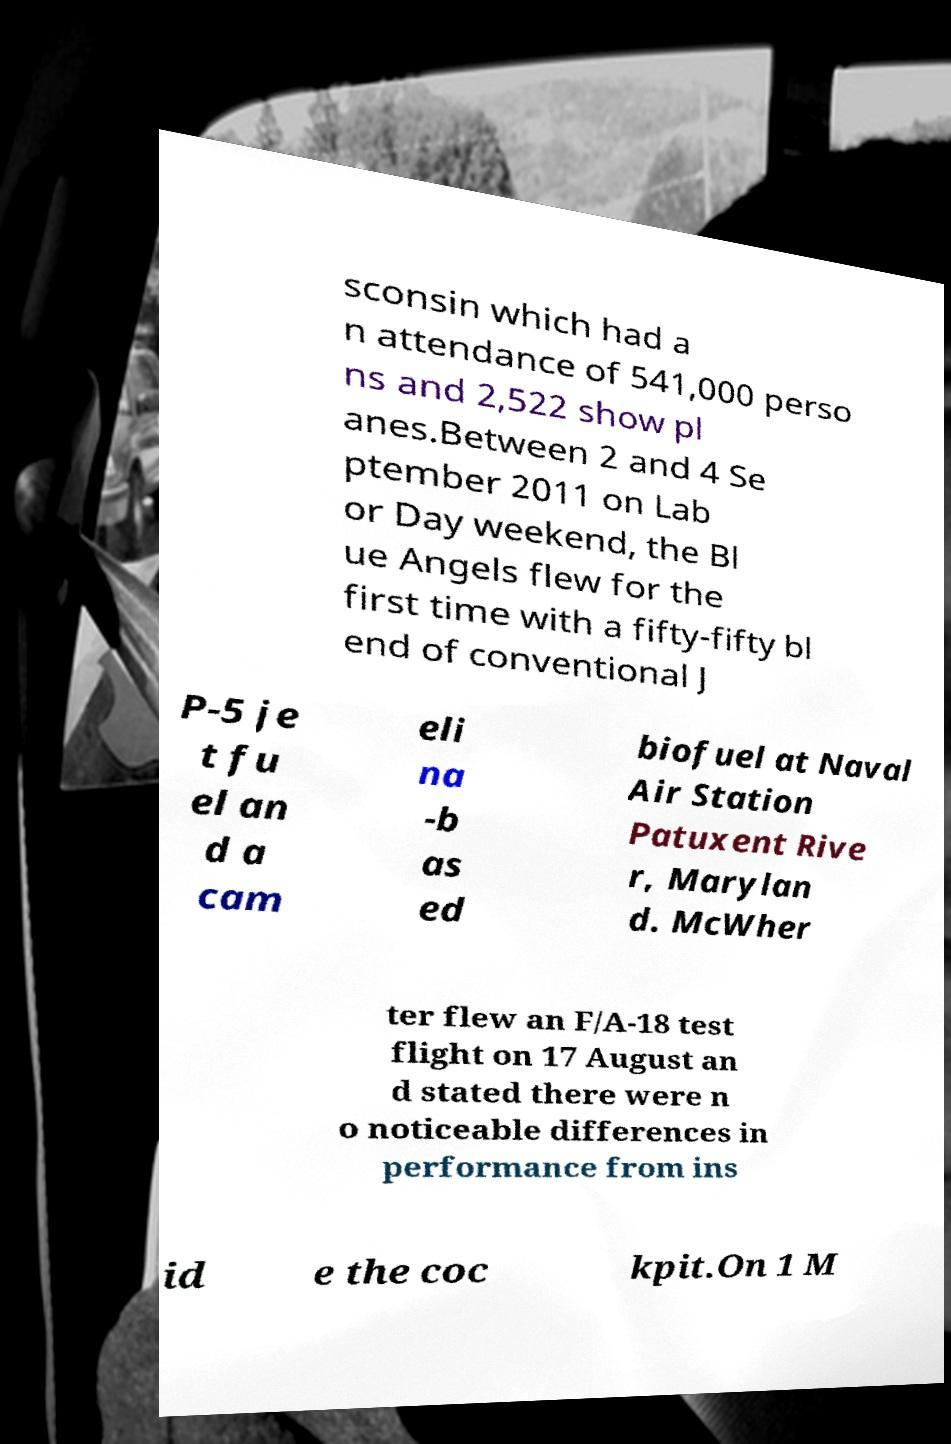Please read and relay the text visible in this image. What does it say? sconsin which had a n attendance of 541,000 perso ns and 2,522 show pl anes.Between 2 and 4 Se ptember 2011 on Lab or Day weekend, the Bl ue Angels flew for the first time with a fifty-fifty bl end of conventional J P-5 je t fu el an d a cam eli na -b as ed biofuel at Naval Air Station Patuxent Rive r, Marylan d. McWher ter flew an F/A-18 test flight on 17 August an d stated there were n o noticeable differences in performance from ins id e the coc kpit.On 1 M 